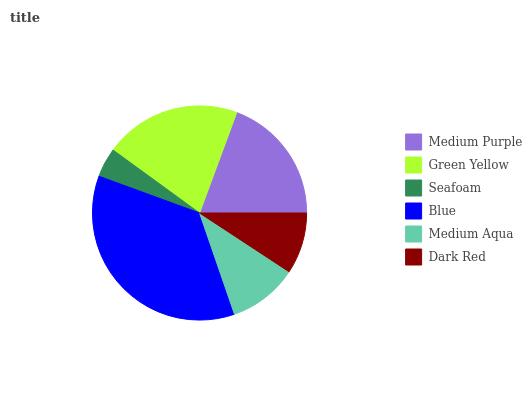Is Seafoam the minimum?
Answer yes or no. Yes. Is Blue the maximum?
Answer yes or no. Yes. Is Green Yellow the minimum?
Answer yes or no. No. Is Green Yellow the maximum?
Answer yes or no. No. Is Green Yellow greater than Medium Purple?
Answer yes or no. Yes. Is Medium Purple less than Green Yellow?
Answer yes or no. Yes. Is Medium Purple greater than Green Yellow?
Answer yes or no. No. Is Green Yellow less than Medium Purple?
Answer yes or no. No. Is Medium Purple the high median?
Answer yes or no. Yes. Is Medium Aqua the low median?
Answer yes or no. Yes. Is Blue the high median?
Answer yes or no. No. Is Seafoam the low median?
Answer yes or no. No. 